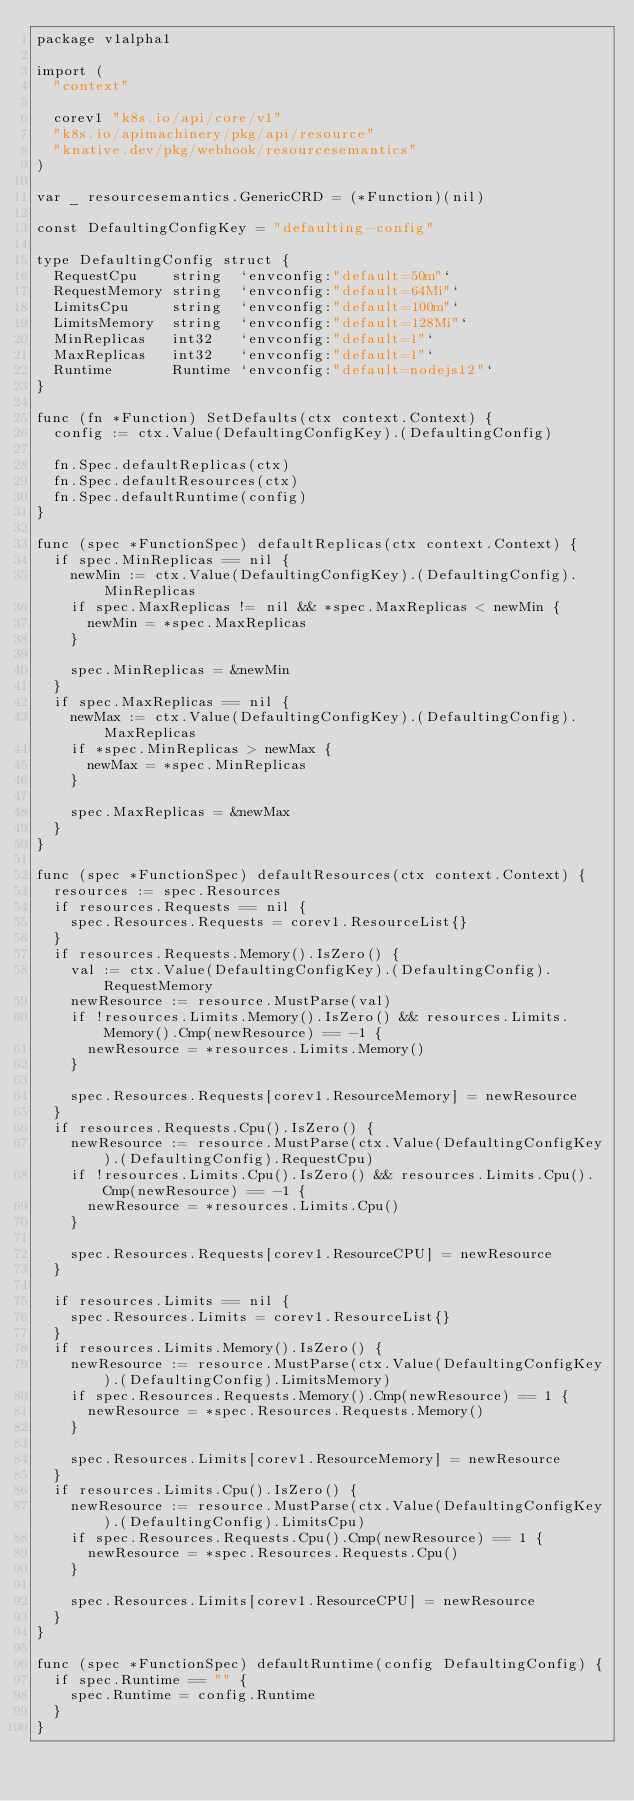Convert code to text. <code><loc_0><loc_0><loc_500><loc_500><_Go_>package v1alpha1

import (
	"context"

	corev1 "k8s.io/api/core/v1"
	"k8s.io/apimachinery/pkg/api/resource"
	"knative.dev/pkg/webhook/resourcesemantics"
)

var _ resourcesemantics.GenericCRD = (*Function)(nil)

const DefaultingConfigKey = "defaulting-config"

type DefaultingConfig struct {
	RequestCpu    string  `envconfig:"default=50m"`
	RequestMemory string  `envconfig:"default=64Mi"`
	LimitsCpu     string  `envconfig:"default=100m"`
	LimitsMemory  string  `envconfig:"default=128Mi"`
	MinReplicas   int32   `envconfig:"default=1"`
	MaxReplicas   int32   `envconfig:"default=1"`
	Runtime       Runtime `envconfig:"default=nodejs12"`
}

func (fn *Function) SetDefaults(ctx context.Context) {
	config := ctx.Value(DefaultingConfigKey).(DefaultingConfig)

	fn.Spec.defaultReplicas(ctx)
	fn.Spec.defaultResources(ctx)
	fn.Spec.defaultRuntime(config)
}

func (spec *FunctionSpec) defaultReplicas(ctx context.Context) {
	if spec.MinReplicas == nil {
		newMin := ctx.Value(DefaultingConfigKey).(DefaultingConfig).MinReplicas
		if spec.MaxReplicas != nil && *spec.MaxReplicas < newMin {
			newMin = *spec.MaxReplicas
		}

		spec.MinReplicas = &newMin
	}
	if spec.MaxReplicas == nil {
		newMax := ctx.Value(DefaultingConfigKey).(DefaultingConfig).MaxReplicas
		if *spec.MinReplicas > newMax {
			newMax = *spec.MinReplicas
		}

		spec.MaxReplicas = &newMax
	}
}

func (spec *FunctionSpec) defaultResources(ctx context.Context) {
	resources := spec.Resources
	if resources.Requests == nil {
		spec.Resources.Requests = corev1.ResourceList{}
	}
	if resources.Requests.Memory().IsZero() {
		val := ctx.Value(DefaultingConfigKey).(DefaultingConfig).RequestMemory
		newResource := resource.MustParse(val)
		if !resources.Limits.Memory().IsZero() && resources.Limits.Memory().Cmp(newResource) == -1 {
			newResource = *resources.Limits.Memory()
		}

		spec.Resources.Requests[corev1.ResourceMemory] = newResource
	}
	if resources.Requests.Cpu().IsZero() {
		newResource := resource.MustParse(ctx.Value(DefaultingConfigKey).(DefaultingConfig).RequestCpu)
		if !resources.Limits.Cpu().IsZero() && resources.Limits.Cpu().Cmp(newResource) == -1 {
			newResource = *resources.Limits.Cpu()
		}

		spec.Resources.Requests[corev1.ResourceCPU] = newResource
	}

	if resources.Limits == nil {
		spec.Resources.Limits = corev1.ResourceList{}
	}
	if resources.Limits.Memory().IsZero() {
		newResource := resource.MustParse(ctx.Value(DefaultingConfigKey).(DefaultingConfig).LimitsMemory)
		if spec.Resources.Requests.Memory().Cmp(newResource) == 1 {
			newResource = *spec.Resources.Requests.Memory()
		}

		spec.Resources.Limits[corev1.ResourceMemory] = newResource
	}
	if resources.Limits.Cpu().IsZero() {
		newResource := resource.MustParse(ctx.Value(DefaultingConfigKey).(DefaultingConfig).LimitsCpu)
		if spec.Resources.Requests.Cpu().Cmp(newResource) == 1 {
			newResource = *spec.Resources.Requests.Cpu()
		}

		spec.Resources.Limits[corev1.ResourceCPU] = newResource
	}
}

func (spec *FunctionSpec) defaultRuntime(config DefaultingConfig) {
	if spec.Runtime == "" {
		spec.Runtime = config.Runtime
	}
}
</code> 